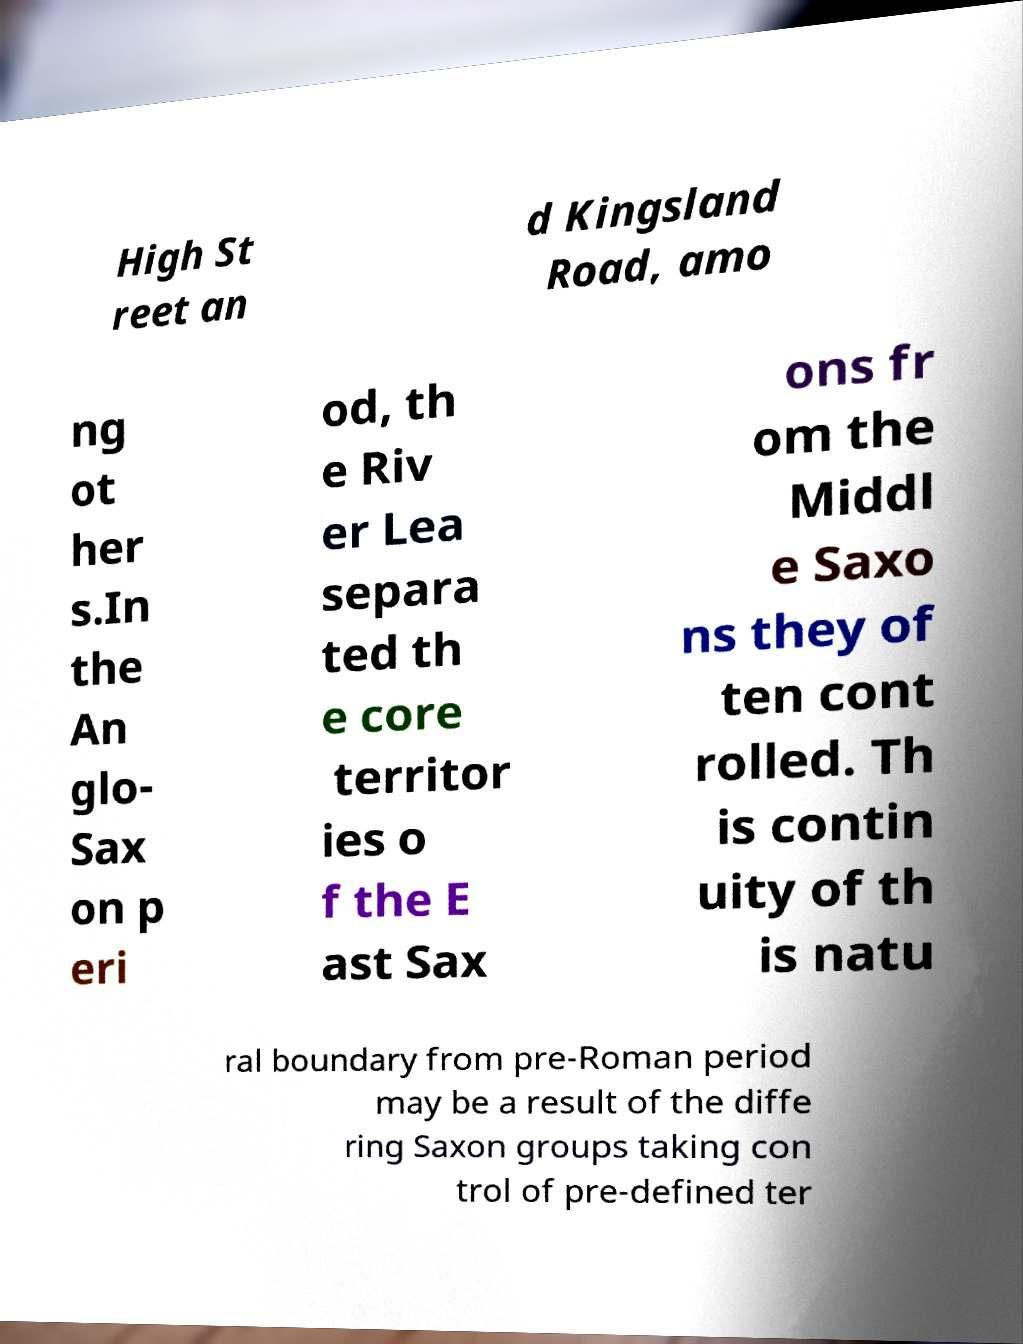What messages or text are displayed in this image? I need them in a readable, typed format. High St reet an d Kingsland Road, amo ng ot her s.In the An glo- Sax on p eri od, th e Riv er Lea separa ted th e core territor ies o f the E ast Sax ons fr om the Middl e Saxo ns they of ten cont rolled. Th is contin uity of th is natu ral boundary from pre-Roman period may be a result of the diffe ring Saxon groups taking con trol of pre-defined ter 